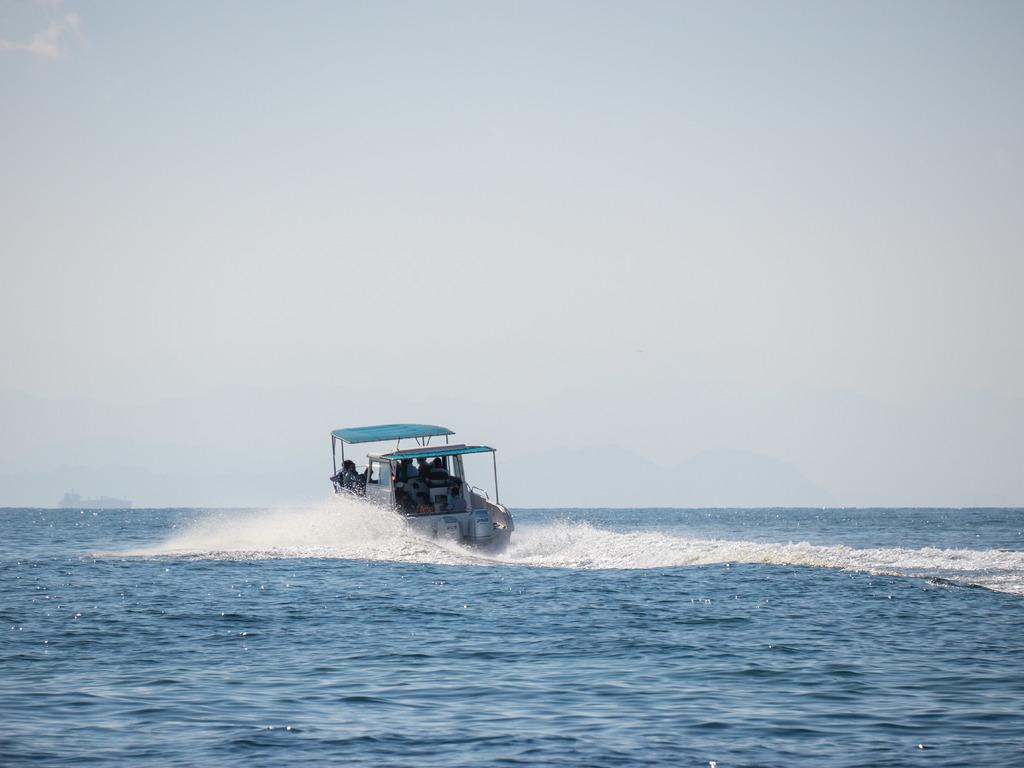What is the main subject of the image? The image depicts an ocean. What can be seen in the middle of the ocean? There is a boat in the middle of the image. What is the boat's location in relation to the water? The boat is on the water. Are there any people visible in the image? Yes, there are people visible inside the boat. What is visible at the top of the image? The sky is visible at the top of the image. What type of stew is being cooked on the boat in the image? There is no indication of any cooking or stew in the image; it simply shows a boat on the water with people inside. 